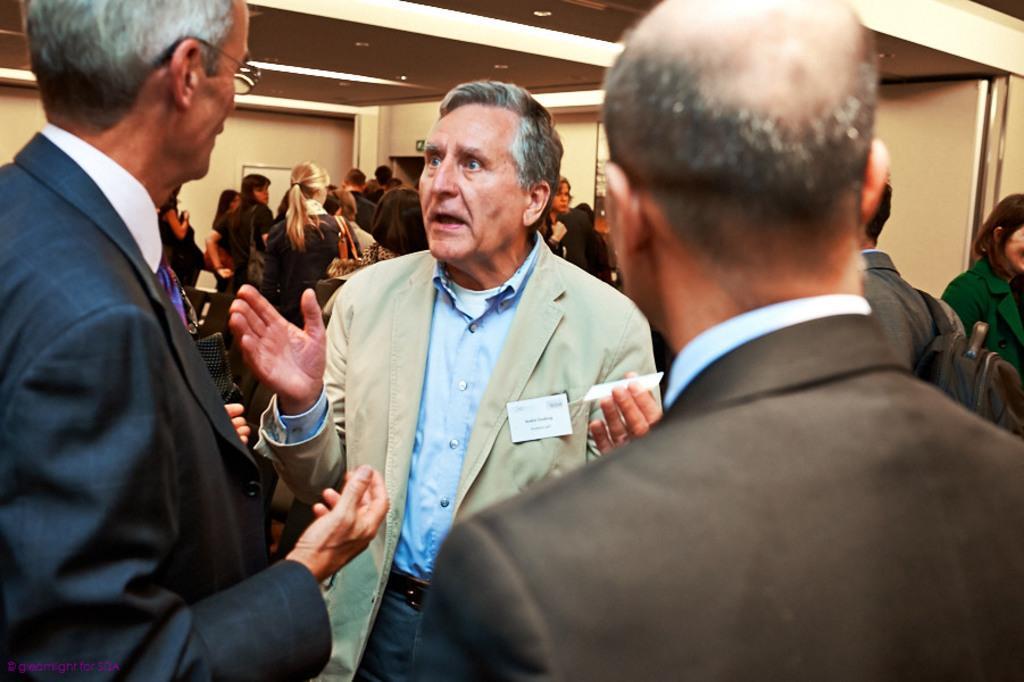How would you summarize this image in a sentence or two? In this picture we can see a group of people standing and a man is holding a card and explaining something. Behind the people there is a wall and at the top there are ceiling lights. 